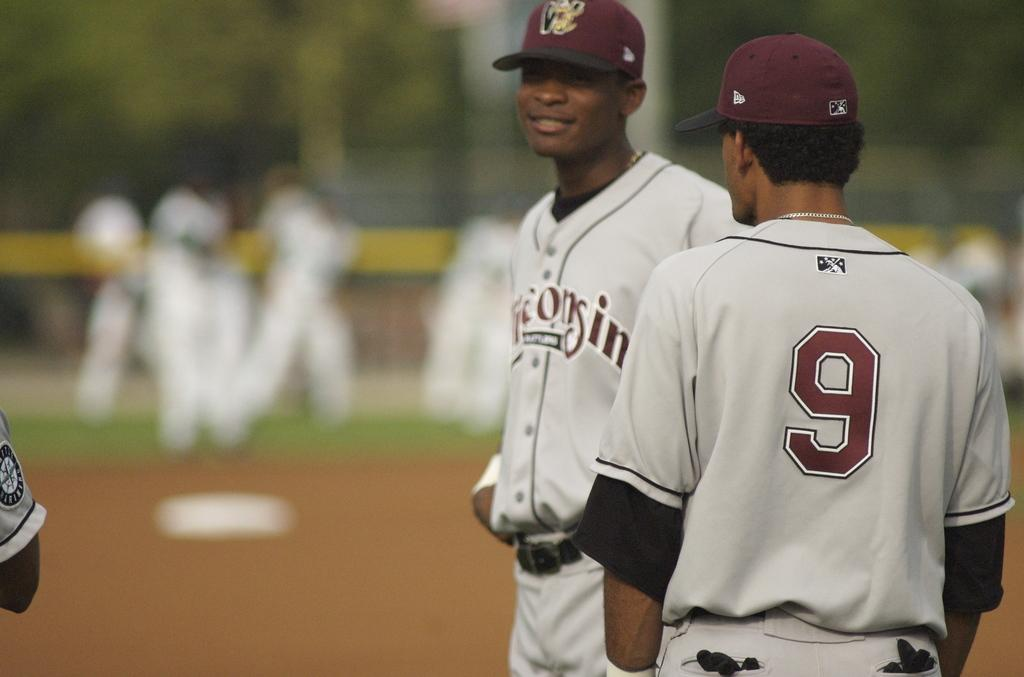<image>
Describe the image concisely. a baseball player wearing a uniform that says '9' 